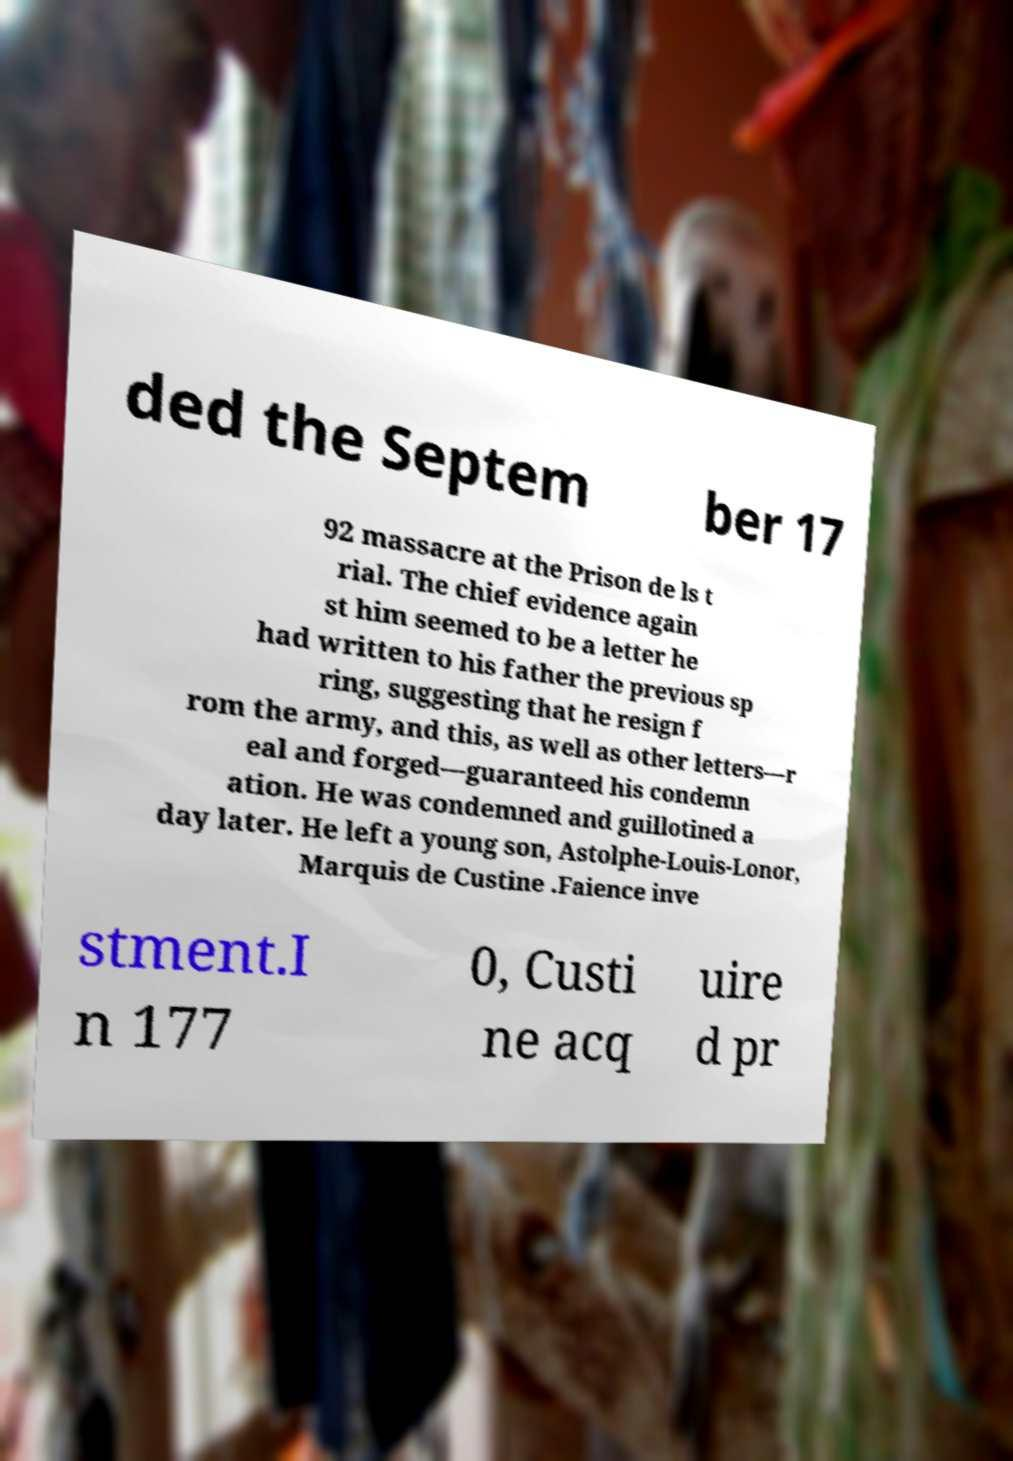Please read and relay the text visible in this image. What does it say? ded the Septem ber 17 92 massacre at the Prison de ls t rial. The chief evidence again st him seemed to be a letter he had written to his father the previous sp ring, suggesting that he resign f rom the army, and this, as well as other letters—r eal and forged—guaranteed his condemn ation. He was condemned and guillotined a day later. He left a young son, Astolphe-Louis-Lonor, Marquis de Custine .Faience inve stment.I n 177 0, Custi ne acq uire d pr 